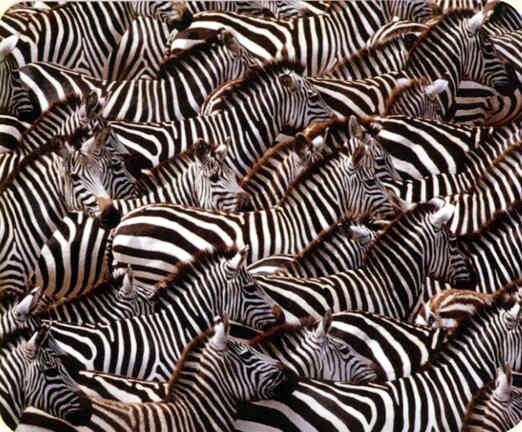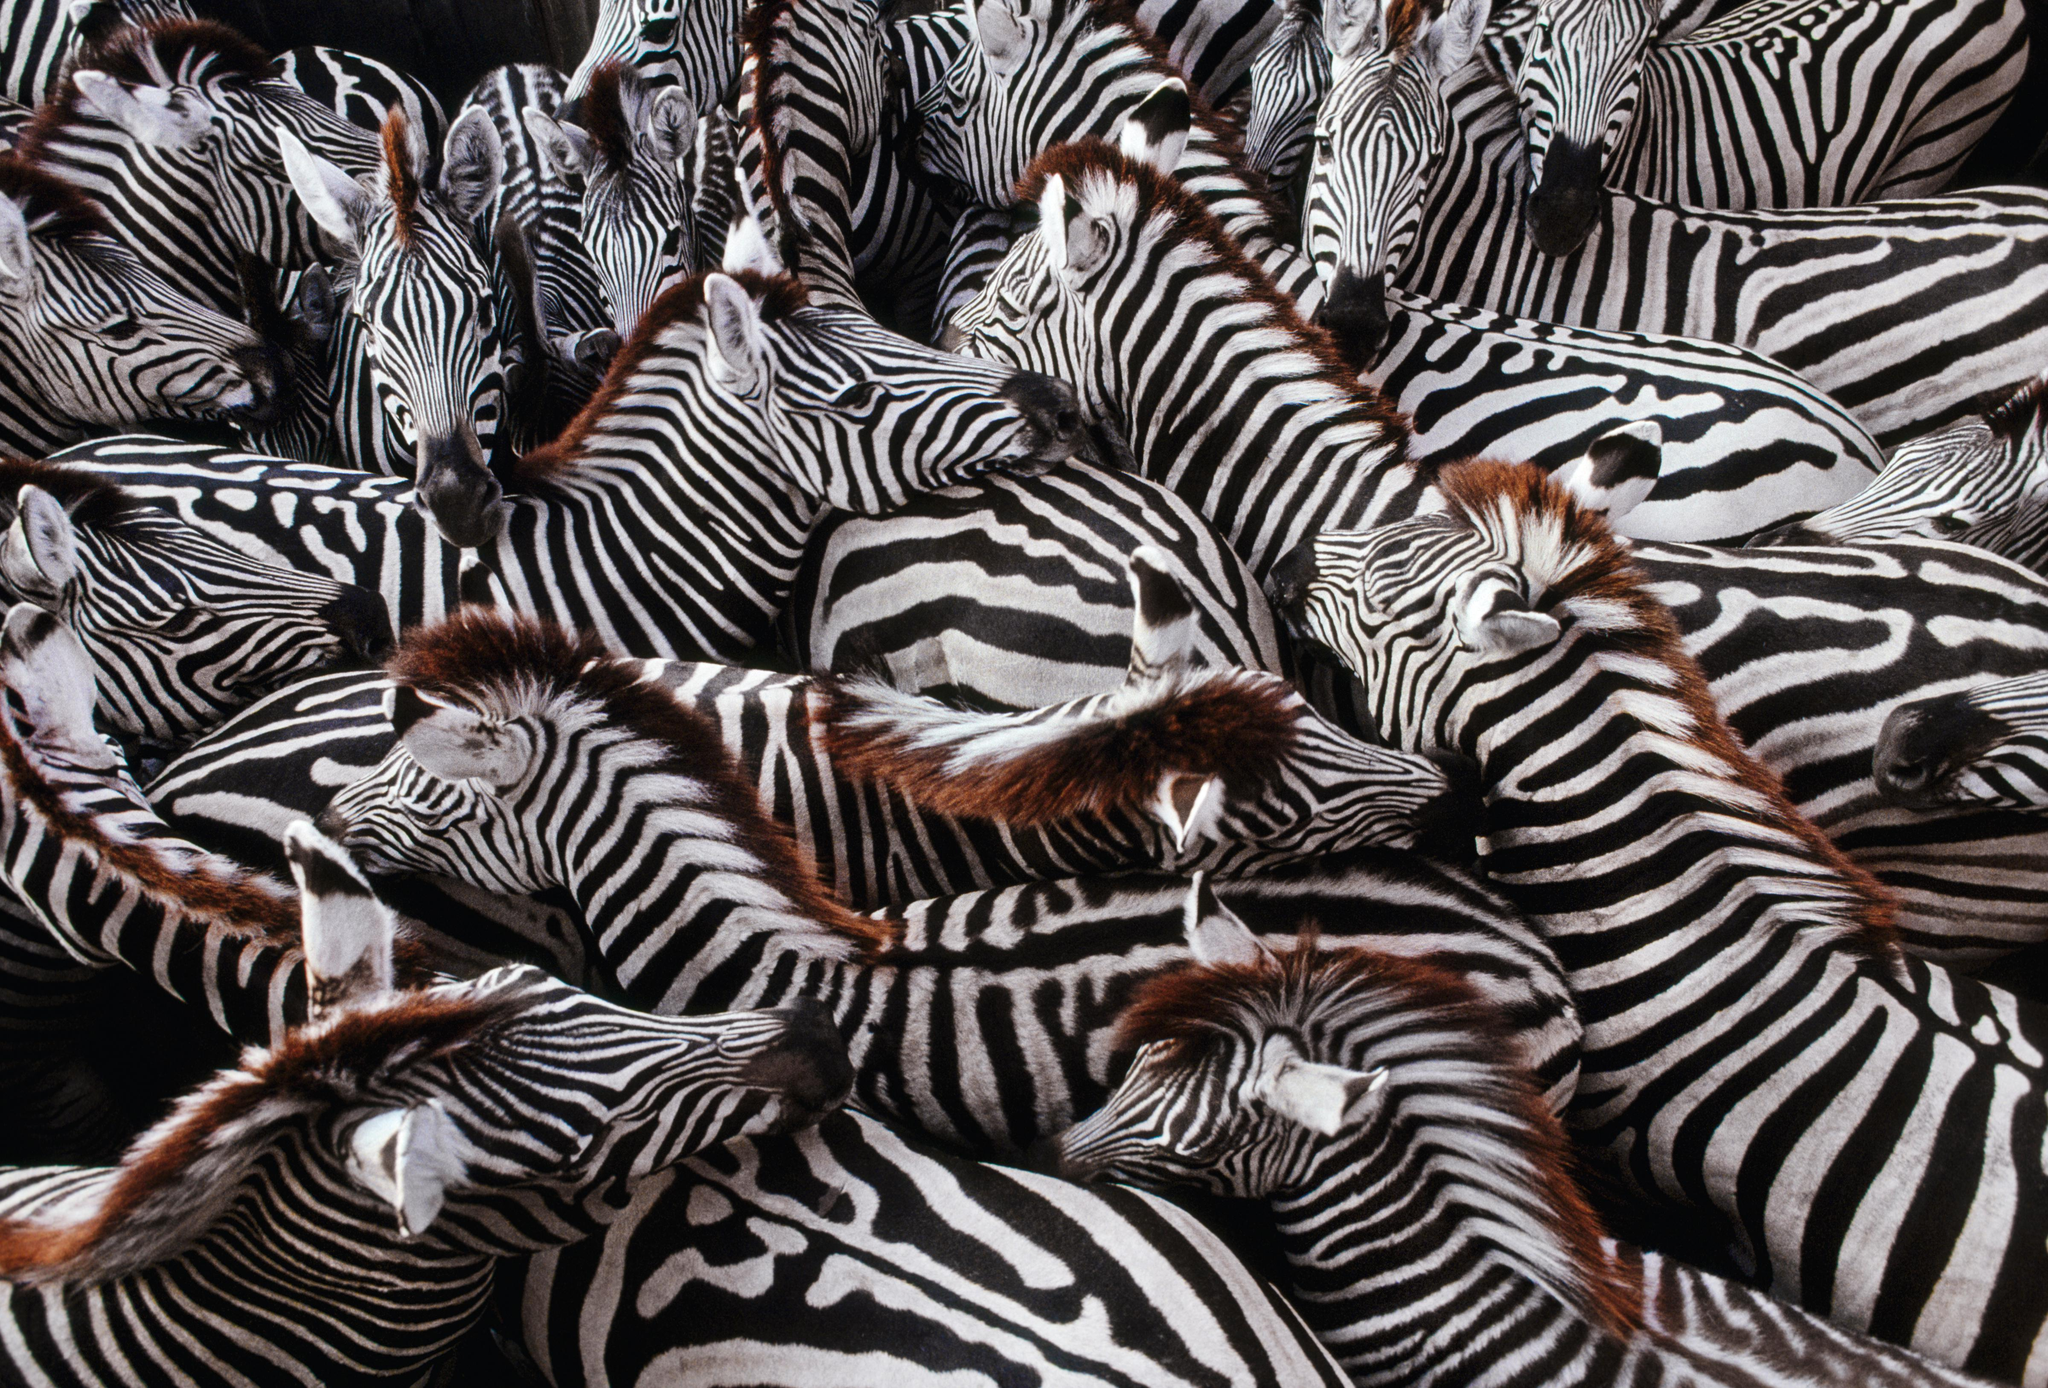The first image is the image on the left, the second image is the image on the right. Evaluate the accuracy of this statement regarding the images: "In at least one image there are at least 8 zebra standing in tall grass.". Is it true? Answer yes or no. No. The first image is the image on the left, the second image is the image on the right. Evaluate the accuracy of this statement regarding the images: "One image shows a mass of zebras with no visible space between or around them, and the other image shows a close grouping of zebras with space above them.". Is it true? Answer yes or no. No. 